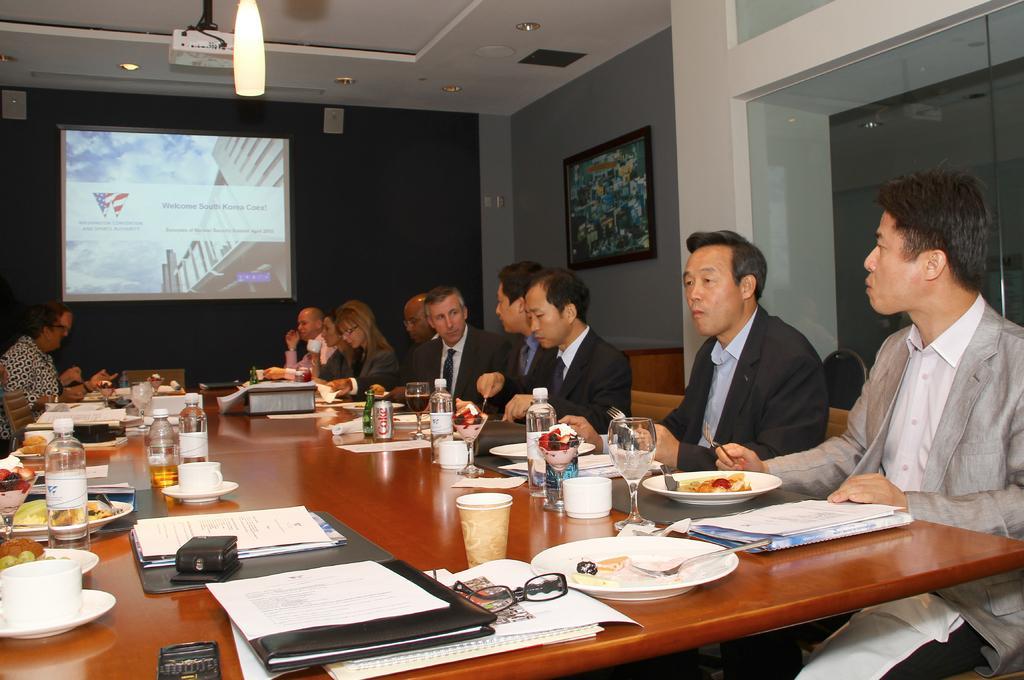Describe this image in one or two sentences. In this image we can see a group of people wearing coats and sitting in front of the table. One person wearing a grey coat is holding a spoon in his hand. On the table we can see the group of bottles, plates with food, spoons, cups, books and spectacles. In the background, we can see a photo frame on the wall, screen and some lights. 